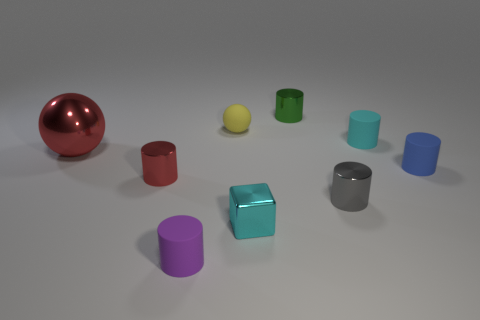Subtract all green shiny cylinders. How many cylinders are left? 5 Subtract 3 cylinders. How many cylinders are left? 3 Add 1 large purple cubes. How many objects exist? 10 Subtract all green cylinders. How many cylinders are left? 5 Subtract all red cylinders. Subtract all yellow blocks. How many cylinders are left? 5 Subtract all blocks. How many objects are left? 8 Add 1 small matte spheres. How many small matte spheres exist? 2 Subtract 1 green cylinders. How many objects are left? 8 Subtract all large blue metal balls. Subtract all small shiny cubes. How many objects are left? 8 Add 7 small red things. How many small red things are left? 8 